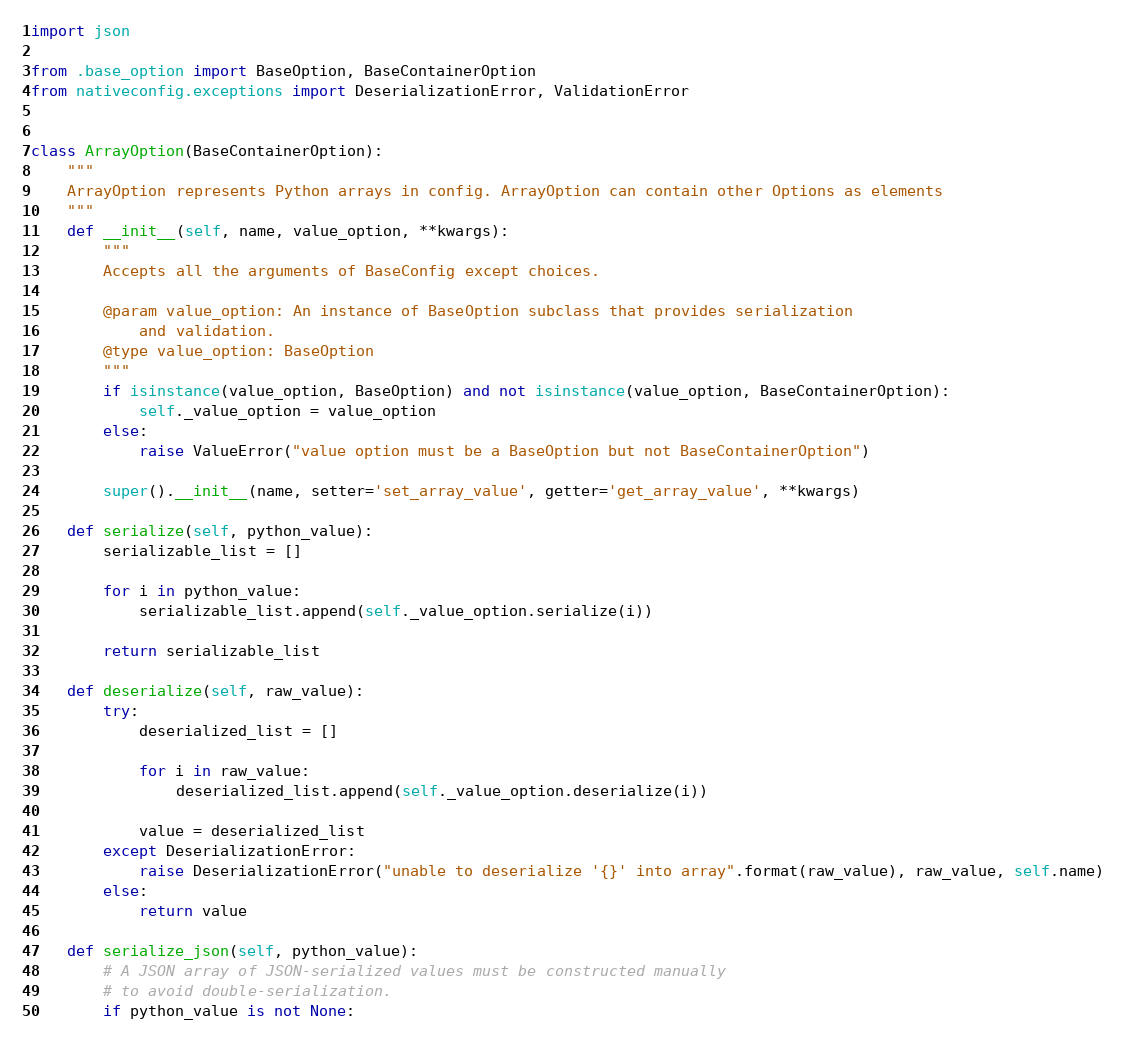<code> <loc_0><loc_0><loc_500><loc_500><_Python_>import json

from .base_option import BaseOption, BaseContainerOption
from nativeconfig.exceptions import DeserializationError, ValidationError


class ArrayOption(BaseContainerOption):
    """
    ArrayOption represents Python arrays in config. ArrayOption can contain other Options as elements
    """
    def __init__(self, name, value_option, **kwargs):
        """
        Accepts all the arguments of BaseConfig except choices.

        @param value_option: An instance of BaseOption subclass that provides serialization
            and validation.
        @type value_option: BaseOption
        """
        if isinstance(value_option, BaseOption) and not isinstance(value_option, BaseContainerOption):
            self._value_option = value_option
        else:
            raise ValueError("value option must be a BaseOption but not BaseContainerOption")

        super().__init__(name, setter='set_array_value', getter='get_array_value', **kwargs)

    def serialize(self, python_value):
        serializable_list = []

        for i in python_value:
            serializable_list.append(self._value_option.serialize(i))

        return serializable_list

    def deserialize(self, raw_value):
        try:
            deserialized_list = []

            for i in raw_value:
                deserialized_list.append(self._value_option.deserialize(i))

            value = deserialized_list
        except DeserializationError:
            raise DeserializationError("unable to deserialize '{}' into array".format(raw_value), raw_value, self.name)
        else:
            return value

    def serialize_json(self, python_value):
        # A JSON array of JSON-serialized values must be constructed manually
        # to avoid double-serialization.
        if python_value is not None:</code> 